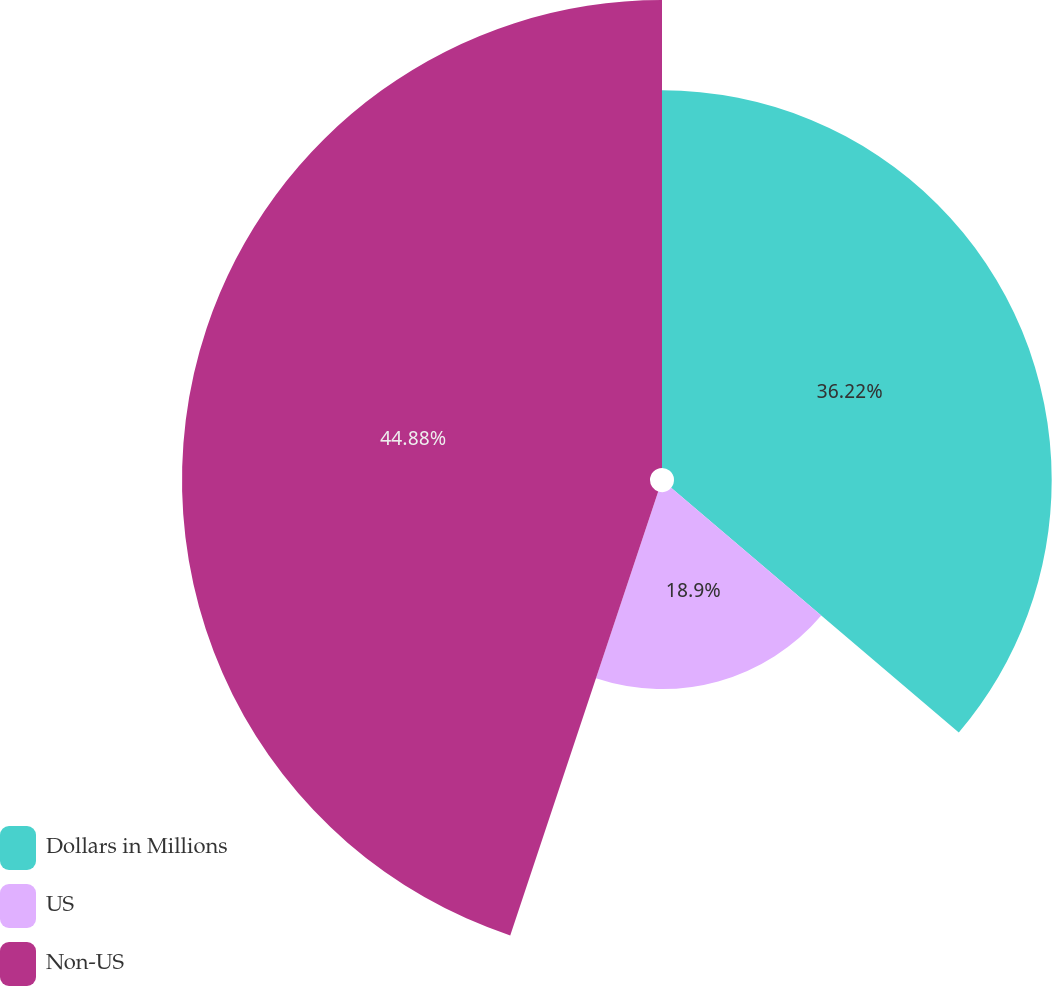Convert chart to OTSL. <chart><loc_0><loc_0><loc_500><loc_500><pie_chart><fcel>Dollars in Millions<fcel>US<fcel>Non-US<nl><fcel>36.22%<fcel>18.9%<fcel>44.88%<nl></chart> 